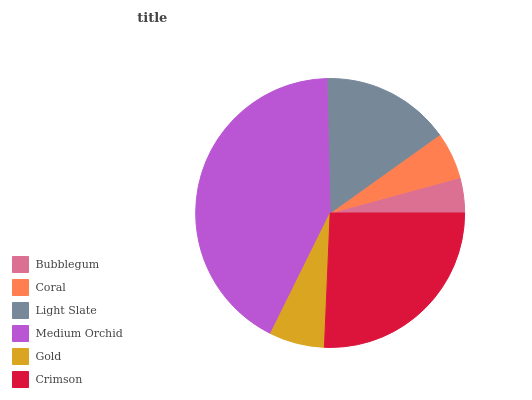Is Bubblegum the minimum?
Answer yes or no. Yes. Is Medium Orchid the maximum?
Answer yes or no. Yes. Is Coral the minimum?
Answer yes or no. No. Is Coral the maximum?
Answer yes or no. No. Is Coral greater than Bubblegum?
Answer yes or no. Yes. Is Bubblegum less than Coral?
Answer yes or no. Yes. Is Bubblegum greater than Coral?
Answer yes or no. No. Is Coral less than Bubblegum?
Answer yes or no. No. Is Light Slate the high median?
Answer yes or no. Yes. Is Gold the low median?
Answer yes or no. Yes. Is Gold the high median?
Answer yes or no. No. Is Light Slate the low median?
Answer yes or no. No. 